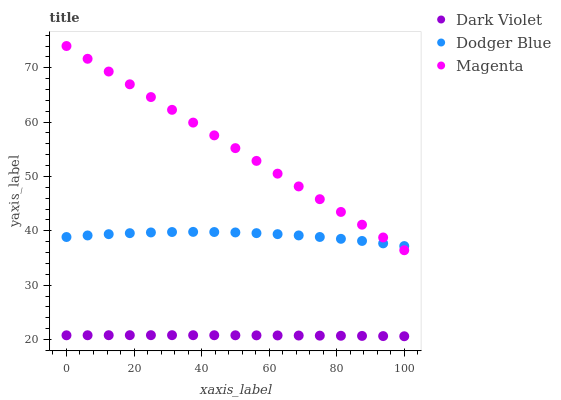Does Dark Violet have the minimum area under the curve?
Answer yes or no. Yes. Does Magenta have the maximum area under the curve?
Answer yes or no. Yes. Does Dodger Blue have the minimum area under the curve?
Answer yes or no. No. Does Dodger Blue have the maximum area under the curve?
Answer yes or no. No. Is Magenta the smoothest?
Answer yes or no. Yes. Is Dodger Blue the roughest?
Answer yes or no. Yes. Is Dark Violet the smoothest?
Answer yes or no. No. Is Dark Violet the roughest?
Answer yes or no. No. Does Dark Violet have the lowest value?
Answer yes or no. Yes. Does Dodger Blue have the lowest value?
Answer yes or no. No. Does Magenta have the highest value?
Answer yes or no. Yes. Does Dodger Blue have the highest value?
Answer yes or no. No. Is Dark Violet less than Dodger Blue?
Answer yes or no. Yes. Is Dodger Blue greater than Dark Violet?
Answer yes or no. Yes. Does Magenta intersect Dodger Blue?
Answer yes or no. Yes. Is Magenta less than Dodger Blue?
Answer yes or no. No. Is Magenta greater than Dodger Blue?
Answer yes or no. No. Does Dark Violet intersect Dodger Blue?
Answer yes or no. No. 